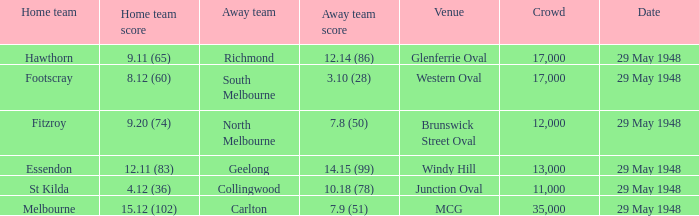In the game where footscray was the host team, what was their score? 8.12 (60). 